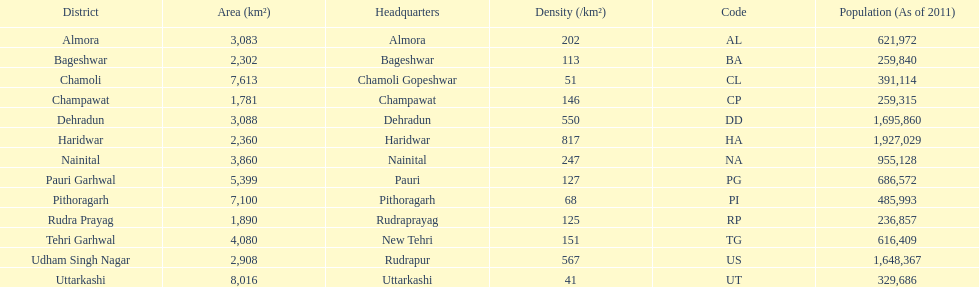Could you help me parse every detail presented in this table? {'header': ['District', 'Area (km²)', 'Headquarters', 'Density (/km²)', 'Code', 'Population (As of 2011)'], 'rows': [['Almora', '3,083', 'Almora', '202', 'AL', '621,972'], ['Bageshwar', '2,302', 'Bageshwar', '113', 'BA', '259,840'], ['Chamoli', '7,613', 'Chamoli Gopeshwar', '51', 'CL', '391,114'], ['Champawat', '1,781', 'Champawat', '146', 'CP', '259,315'], ['Dehradun', '3,088', 'Dehradun', '550', 'DD', '1,695,860'], ['Haridwar', '2,360', 'Haridwar', '817', 'HA', '1,927,029'], ['Nainital', '3,860', 'Nainital', '247', 'NA', '955,128'], ['Pauri Garhwal', '5,399', 'Pauri', '127', 'PG', '686,572'], ['Pithoragarh', '7,100', 'Pithoragarh', '68', 'PI', '485,993'], ['Rudra Prayag', '1,890', 'Rudraprayag', '125', 'RP', '236,857'], ['Tehri Garhwal', '4,080', 'New Tehri', '151', 'TG', '616,409'], ['Udham Singh Nagar', '2,908', 'Rudrapur', '567', 'US', '1,648,367'], ['Uttarkashi', '8,016', 'Uttarkashi', '41', 'UT', '329,686']]} Tell me a district that only has a density of 51. Chamoli. 